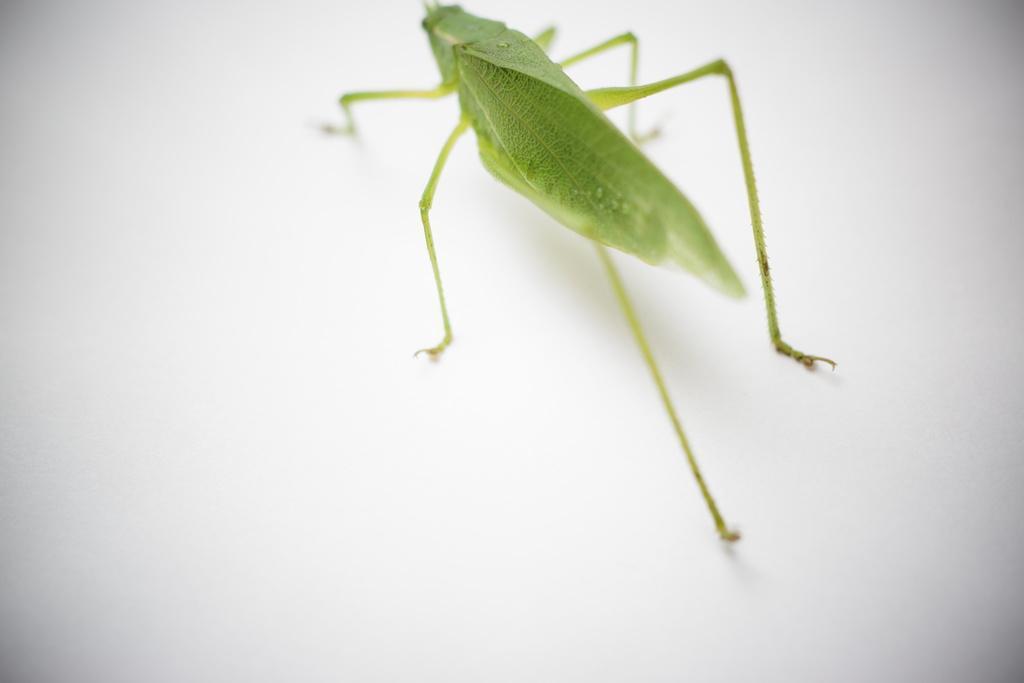Please provide a concise description of this image. In this picture there is a grasshopper. At the bottom there is a white background and this is an edited picture. 